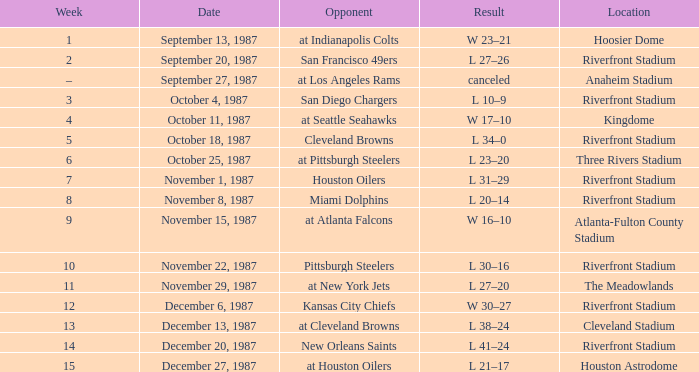After week 8, what was the conclusion of the game held at riverfront stadium? L 20–14. 